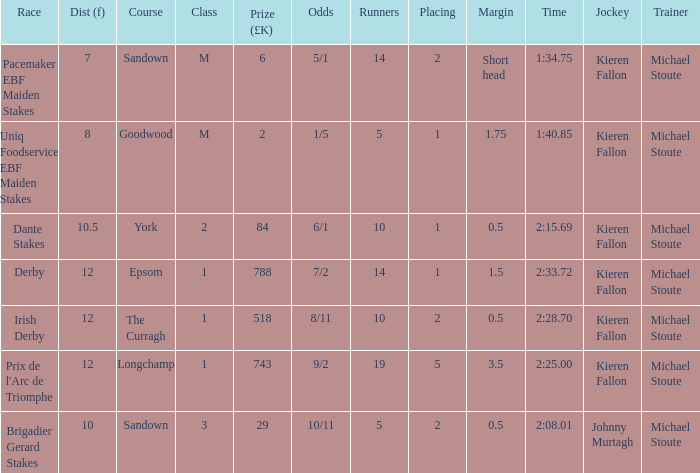Name the runners for longchamp 19.0. Could you parse the entire table? {'header': ['Race', 'Dist (f)', 'Course', 'Class', 'Prize (£K)', 'Odds', 'Runners', 'Placing', 'Margin', 'Time', 'Jockey', 'Trainer'], 'rows': [['Pacemaker EBF Maiden Stakes', '7', 'Sandown', 'M', '6', '5/1', '14', '2', 'Short head', '1:34.75', 'Kieren Fallon', 'Michael Stoute'], ['Uniq Foodservice EBF Maiden Stakes', '8', 'Goodwood', 'M', '2', '1/5', '5', '1', '1.75', '1:40.85', 'Kieren Fallon', 'Michael Stoute'], ['Dante Stakes', '10.5', 'York', '2', '84', '6/1', '10', '1', '0.5', '2:15.69', 'Kieren Fallon', 'Michael Stoute'], ['Derby', '12', 'Epsom', '1', '788', '7/2', '14', '1', '1.5', '2:33.72', 'Kieren Fallon', 'Michael Stoute'], ['Irish Derby', '12', 'The Curragh', '1', '518', '8/11', '10', '2', '0.5', '2:28.70', 'Kieren Fallon', 'Michael Stoute'], ["Prix de l'Arc de Triomphe", '12', 'Longchamp', '1', '743', '9/2', '19', '5', '3.5', '2:25.00', 'Kieren Fallon', 'Michael Stoute'], ['Brigadier Gerard Stakes', '10', 'Sandown', '3', '29', '10/11', '5', '2', '0.5', '2:08.01', 'Johnny Murtagh', 'Michael Stoute']]} 